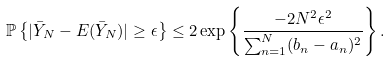Convert formula to latex. <formula><loc_0><loc_0><loc_500><loc_500>\mathbb { P } \left \{ | \bar { Y } _ { N } - E ( \bar { Y } _ { N } ) | \geq \epsilon \right \} \leq 2 \exp \left \{ \frac { - 2 N ^ { 2 } \epsilon ^ { 2 } } { \sum _ { n = 1 } ^ { N } ( b _ { n } - a _ { n } ) ^ { 2 } } \right \} .</formula> 